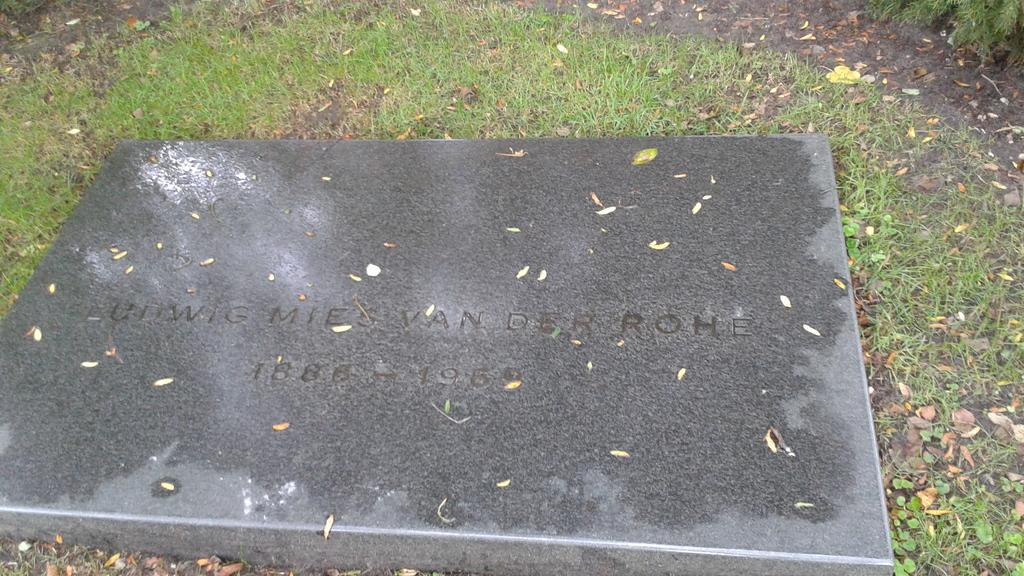What type of vegetation can be seen in the image? There are dry leaves and grass in the image. What is the primary object in the image? There is a gravestone in the image. What type of ground is visible in the image? Soil is visible at the bottom and top of the image. What color is the crayon used to draw on the gravestone in the image? There is no crayon present in the image, and therefore no such drawing can be observed. What type of government is depicted in the image? There is no reference to any government in the image. 